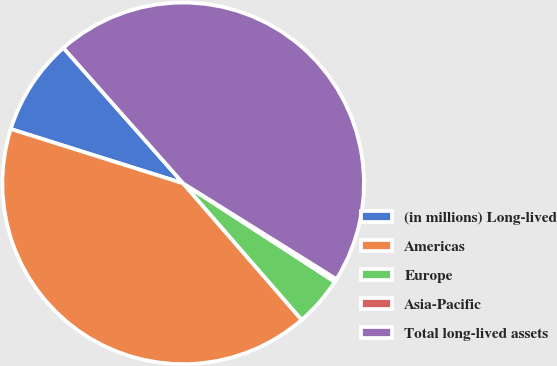<chart> <loc_0><loc_0><loc_500><loc_500><pie_chart><fcel>(in millions) Long-lived<fcel>Americas<fcel>Europe<fcel>Asia-Pacific<fcel>Total long-lived assets<nl><fcel>8.62%<fcel>41.24%<fcel>4.45%<fcel>0.28%<fcel>45.41%<nl></chart> 